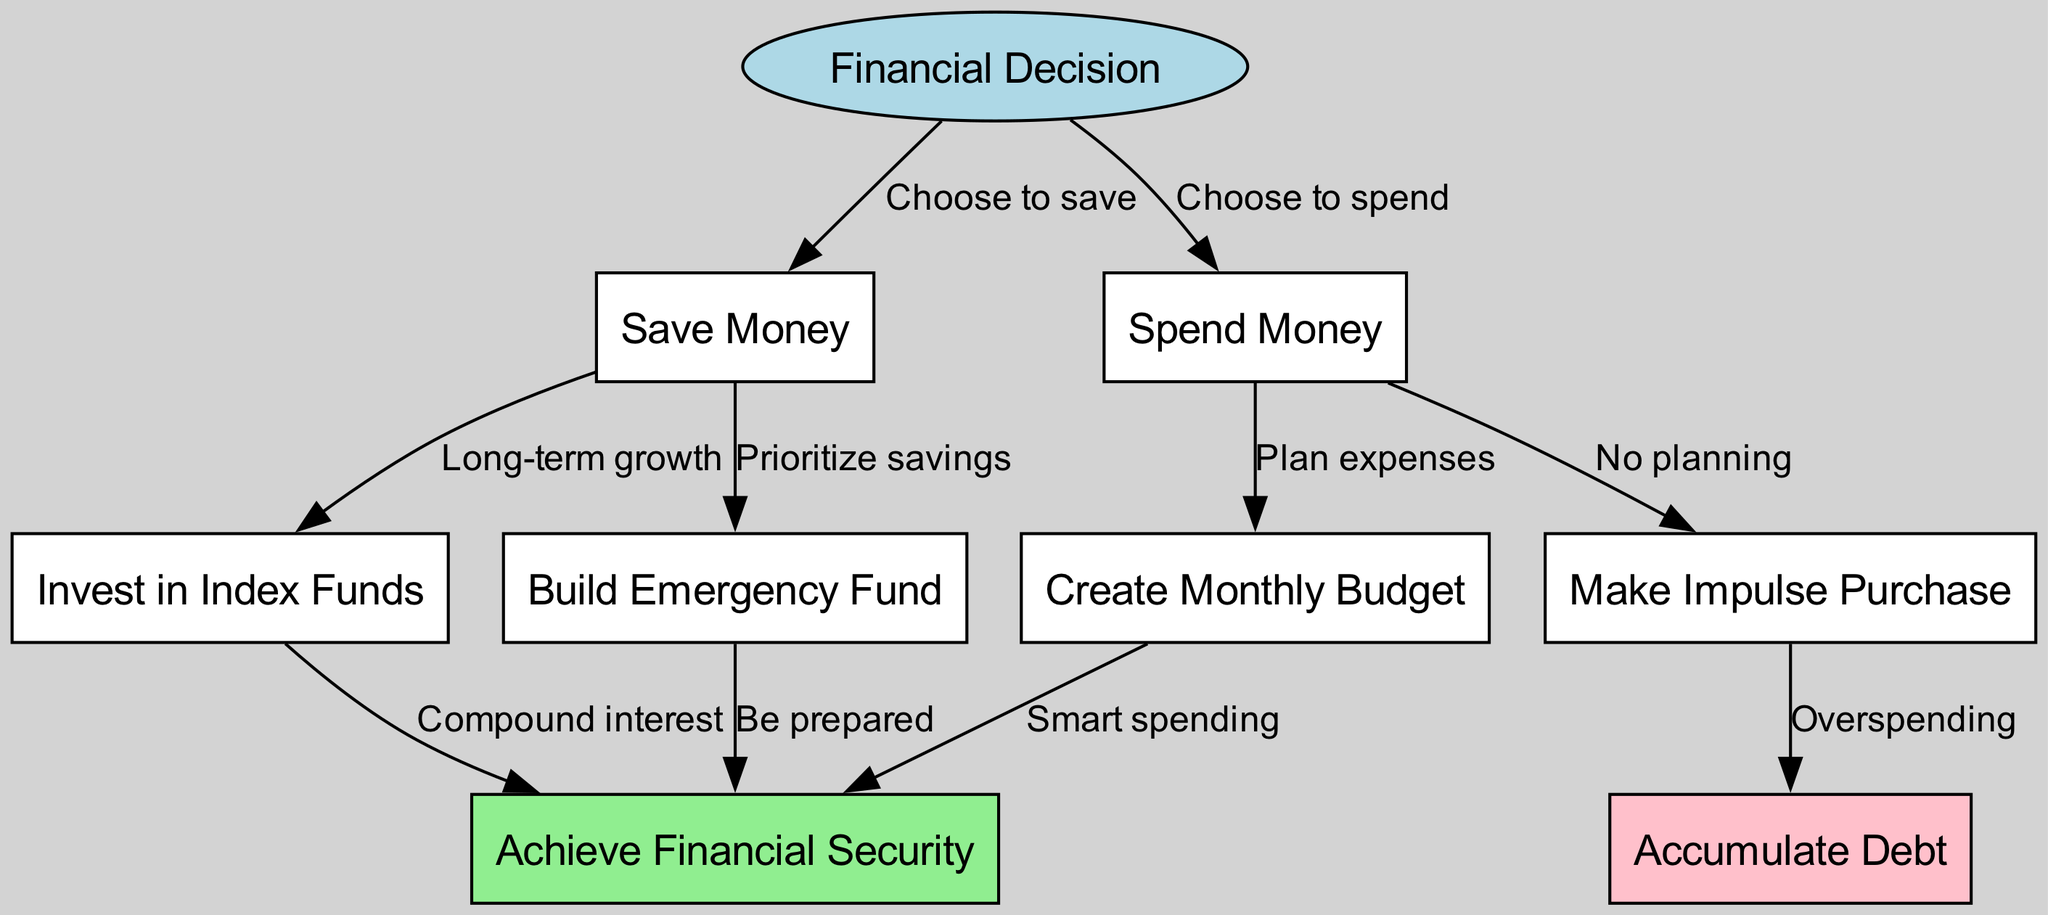What is the starting point of the decision tree? The starting point is labeled "Financial Decision," which represents the initial choice that leads to either saving or spending money.
Answer: Financial Decision How many total nodes are present in the diagram? The diagram contains 9 distinct nodes representing various financial decision points.
Answer: 9 What is the outcome of prioritizing savings? By prioritizing savings, the next step is to "Build Emergency Fund," which reflects the importance of having savings set aside for unexpected expenses.
Answer: Build Emergency Fund Which option leads to accumulating debt? Accumulating debt occurs as a result of making an "Impulse Purchase," indicating a lack of planning and control over spending.
Answer: Impulse Purchase If I choose to spend and then create a budget, what will be the outcome? Choosing to spend initially leads to creating a budget, which then connects to "Achieve Financial Security," demonstrating that smart planning can lead to stable finances even after a spending decision.
Answer: Achieve Financial Security What leads to achieving financial security as a result of saving? Achieving financial security can come from building an emergency fund and investing, both of which are outcomes of prioritizing savings and pursuing long-term financial strategies.
Answer: Emergency Fund, Invest What type of decisions are represented as leading immediately to impulse buying? The diagram shows that spending money without planning leads directly to making impulse purchases, indicating poor financial decision-making.
Answer: No planning What are the color coding rules for the nodes representing financial outcomes? The financial outcomes are color-coded where "Achieve Financial Security" is light green, while "Accumulate Debt" is pink, indicating positive versus negative financial results.
Answer: Light green, pink What happens if I choose to invest? By choosing to invest in index funds, the outcome is "Achieve Financial Security," highlighting the positive effect of long-term investment strategies.
Answer: Achieve Financial Security 